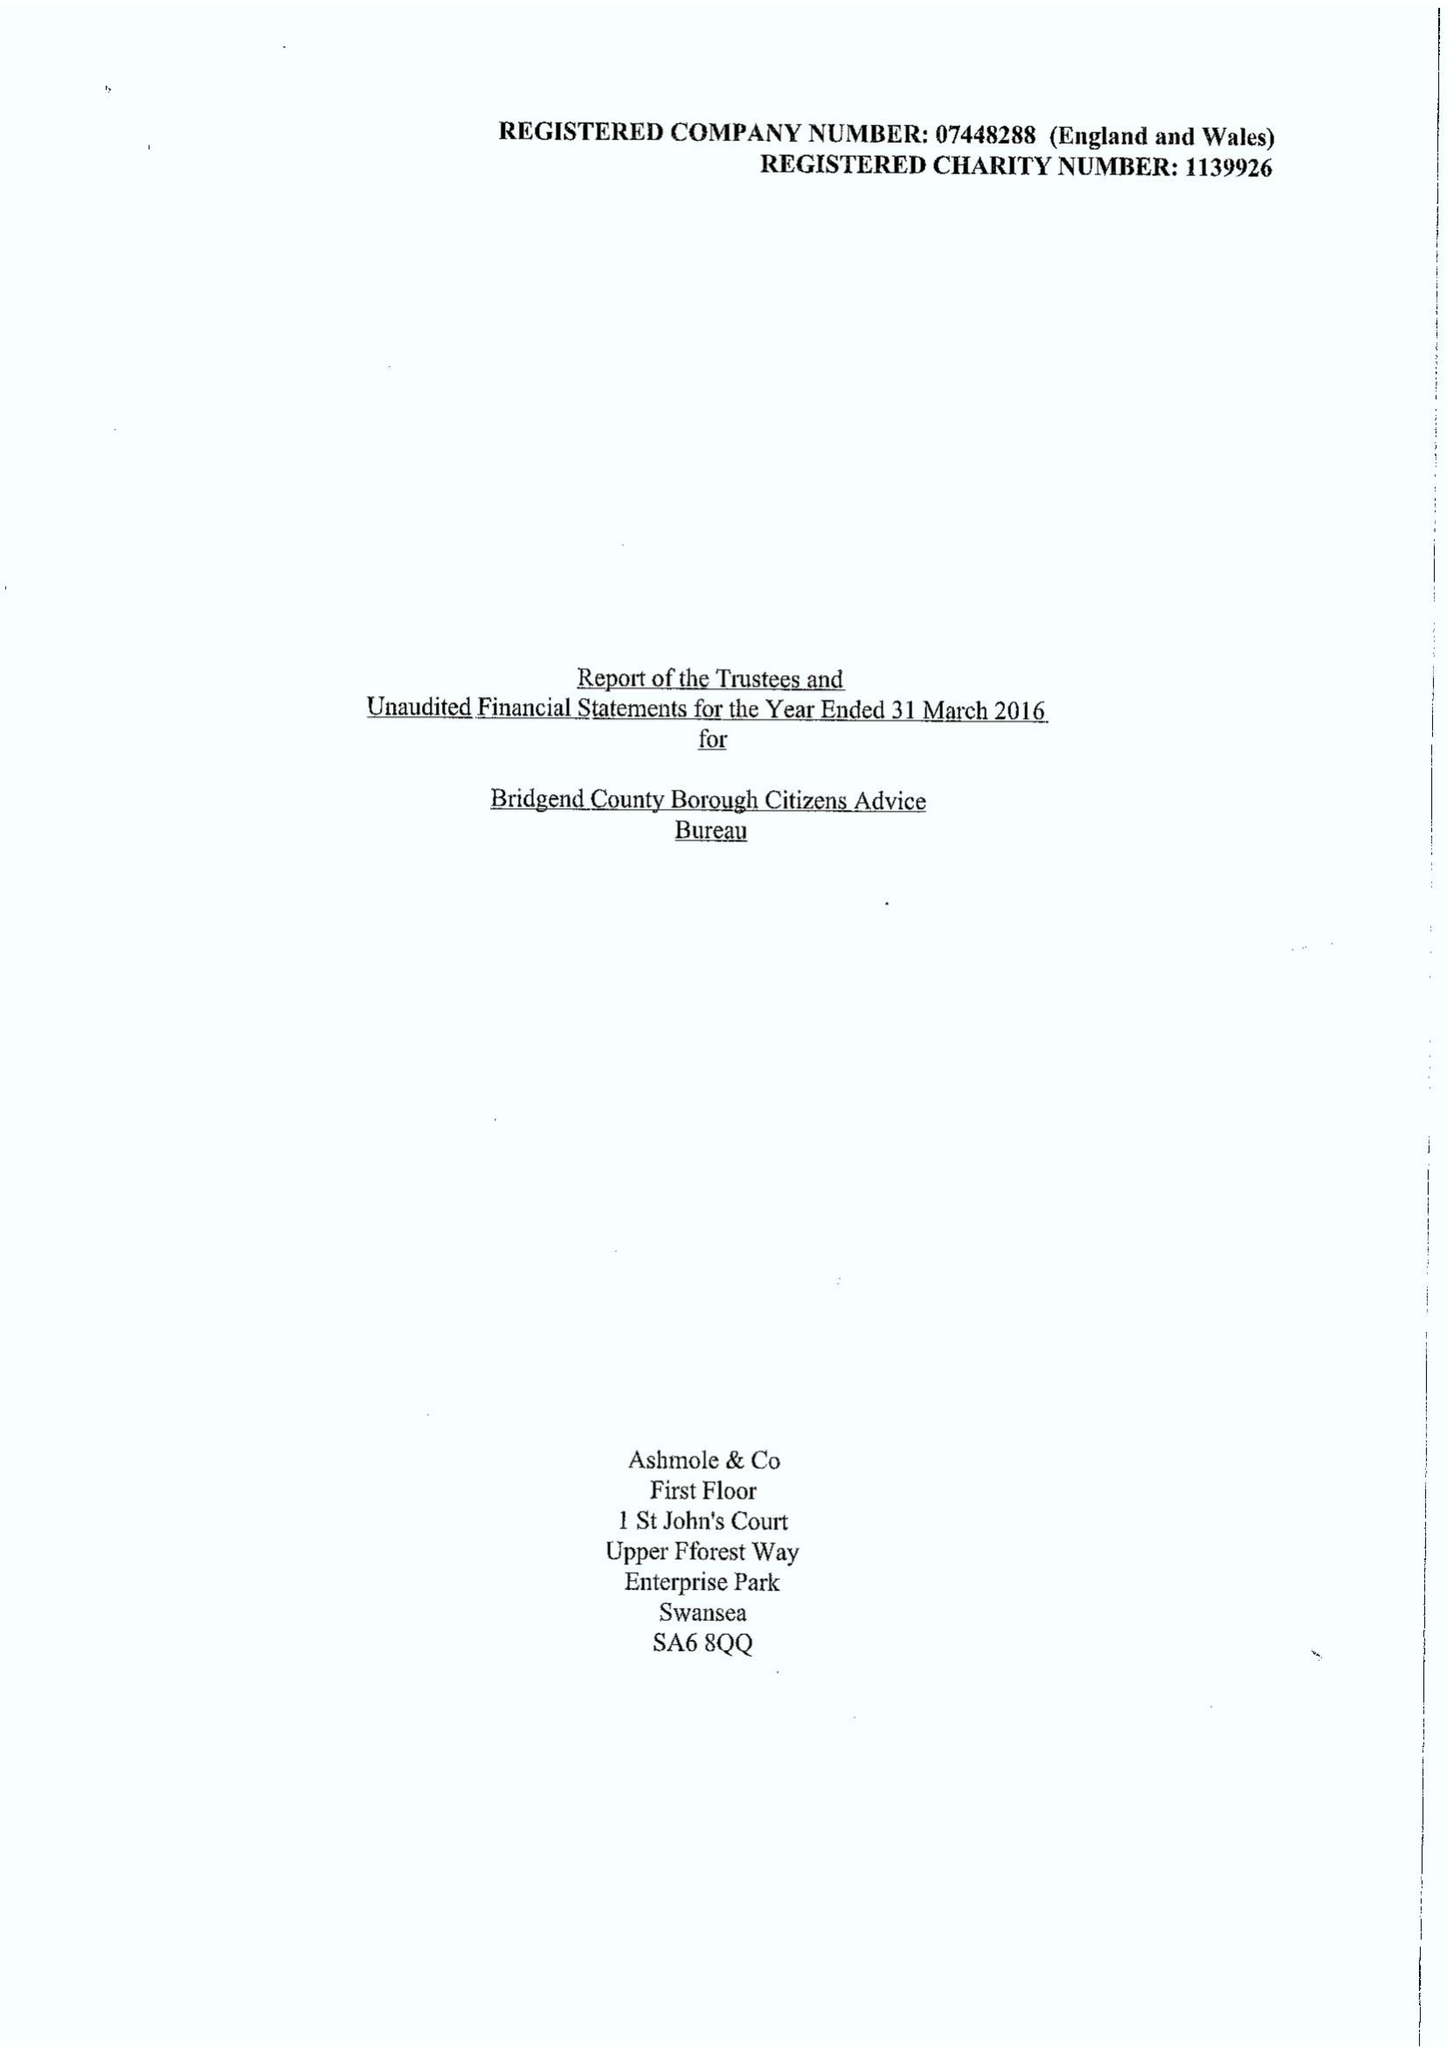What is the value for the income_annually_in_british_pounds?
Answer the question using a single word or phrase. 468133.00 